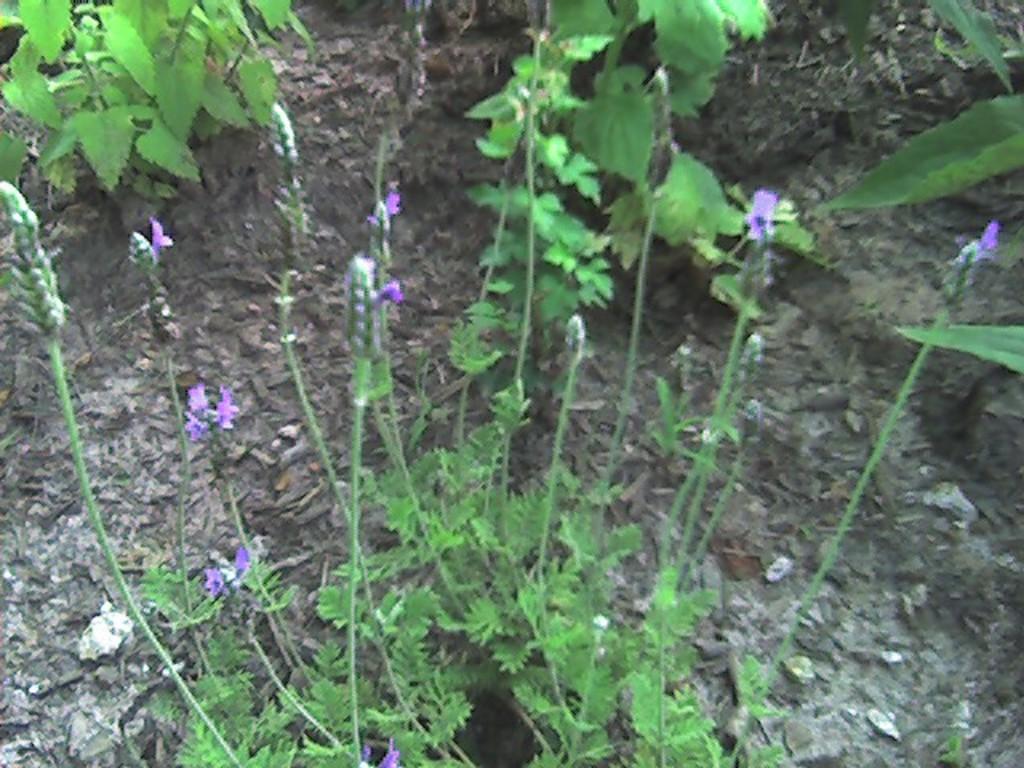Describe this image in one or two sentences. In this image in the middle there are plants, flowers, buds, leaves and stems. At the top there are plants. In the background there is land. 